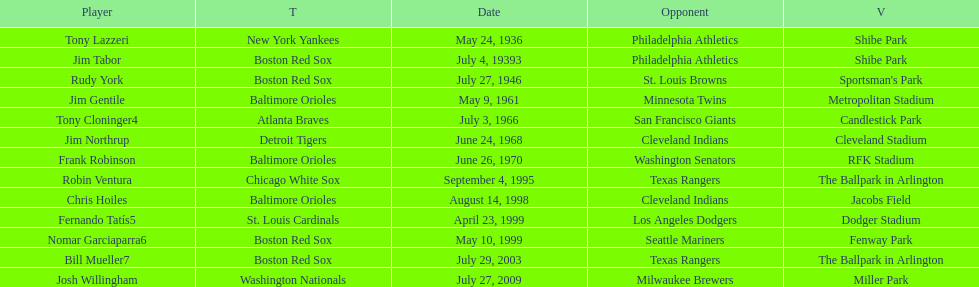Who was the opponent for the boston red sox on july 27, 1946? St. Louis Browns. 